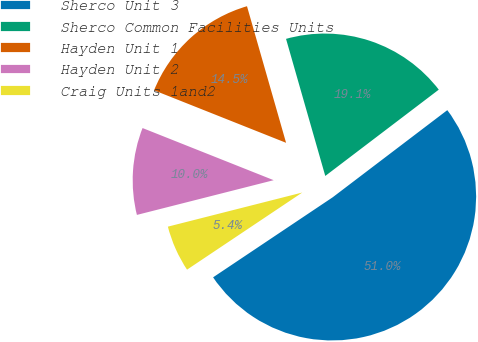<chart> <loc_0><loc_0><loc_500><loc_500><pie_chart><fcel>Sherco Unit 3<fcel>Sherco Common Facilities Units<fcel>Hayden Unit 1<fcel>Hayden Unit 2<fcel>Craig Units 1and2<nl><fcel>50.96%<fcel>19.09%<fcel>14.54%<fcel>9.98%<fcel>5.43%<nl></chart> 